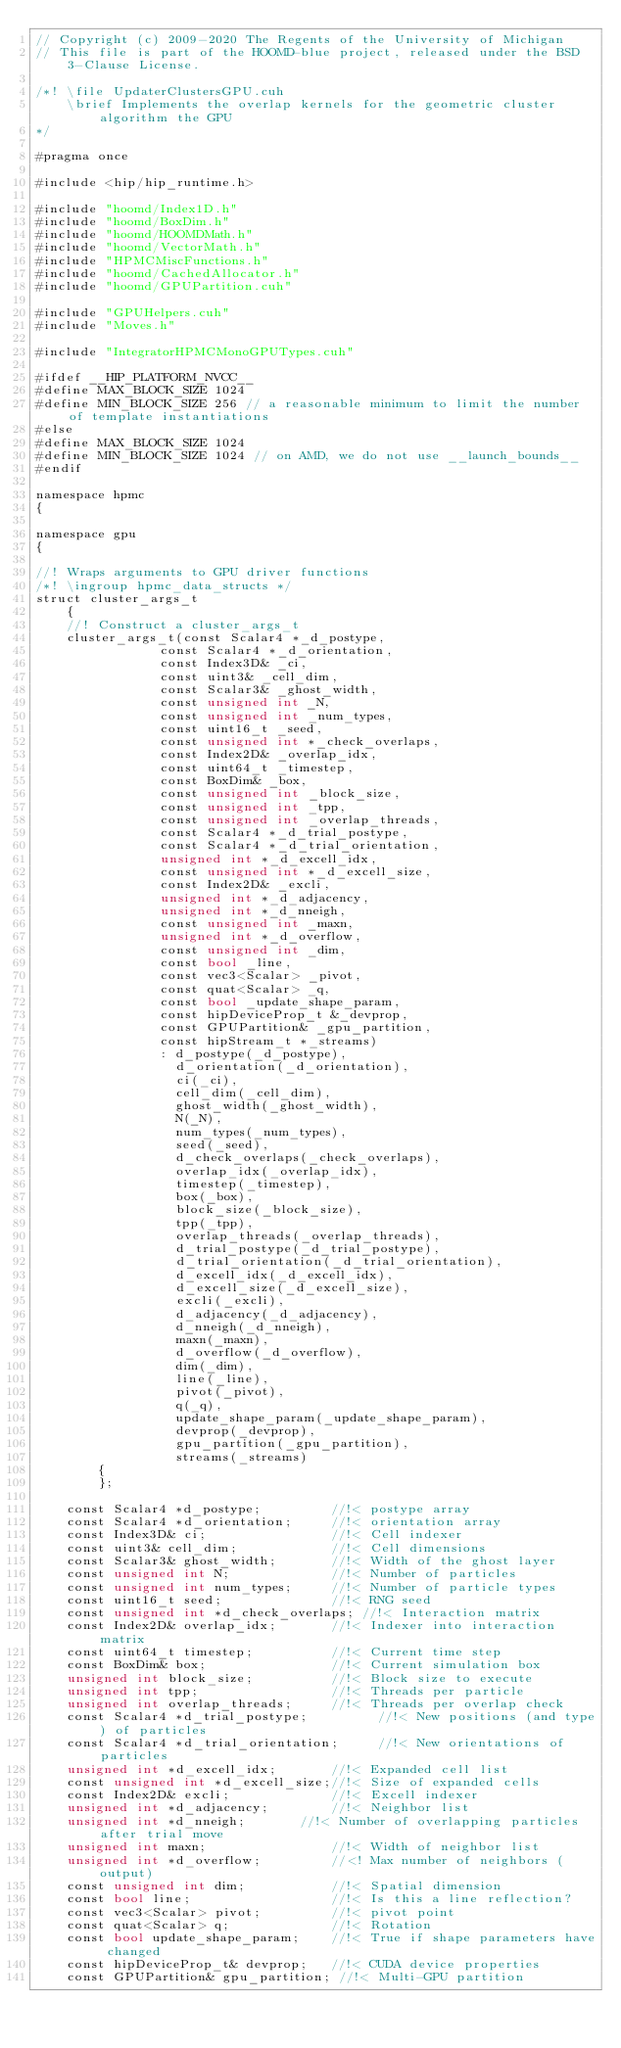<code> <loc_0><loc_0><loc_500><loc_500><_Cuda_>// Copyright (c) 2009-2020 The Regents of the University of Michigan
// This file is part of the HOOMD-blue project, released under the BSD 3-Clause License.

/*! \file UpdaterClustersGPU.cuh
    \brief Implements the overlap kernels for the geometric cluster algorithm the GPU
*/

#pragma once

#include <hip/hip_runtime.h>

#include "hoomd/Index1D.h"
#include "hoomd/BoxDim.h"
#include "hoomd/HOOMDMath.h"
#include "hoomd/VectorMath.h"
#include "HPMCMiscFunctions.h"
#include "hoomd/CachedAllocator.h"
#include "hoomd/GPUPartition.cuh"

#include "GPUHelpers.cuh"
#include "Moves.h"

#include "IntegratorHPMCMonoGPUTypes.cuh"

#ifdef __HIP_PLATFORM_NVCC__
#define MAX_BLOCK_SIZE 1024
#define MIN_BLOCK_SIZE 256 // a reasonable minimum to limit the number of template instantiations
#else
#define MAX_BLOCK_SIZE 1024
#define MIN_BLOCK_SIZE 1024 // on AMD, we do not use __launch_bounds__
#endif

namespace hpmc
{

namespace gpu
{

//! Wraps arguments to GPU driver functions
/*! \ingroup hpmc_data_structs */
struct cluster_args_t
    {
    //! Construct a cluster_args_t
    cluster_args_t(const Scalar4 *_d_postype,
                const Scalar4 *_d_orientation,
                const Index3D& _ci,
                const uint3& _cell_dim,
                const Scalar3& _ghost_width,
                const unsigned int _N,
                const unsigned int _num_types,
                const uint16_t _seed,
                const unsigned int *_check_overlaps,
                const Index2D& _overlap_idx,
                const uint64_t _timestep,
                const BoxDim& _box,
                const unsigned int _block_size,
                const unsigned int _tpp,
                const unsigned int _overlap_threads,
                const Scalar4 *_d_trial_postype,
                const Scalar4 *_d_trial_orientation,
                unsigned int *_d_excell_idx,
                const unsigned int *_d_excell_size,
                const Index2D& _excli,
                unsigned int *_d_adjacency,
                unsigned int *_d_nneigh,
                const unsigned int _maxn,
                unsigned int *_d_overflow,
                const unsigned int _dim,
                const bool _line,
                const vec3<Scalar> _pivot,
                const quat<Scalar> _q,
                const bool _update_shape_param,
                const hipDeviceProp_t &_devprop,
                const GPUPartition& _gpu_partition,
                const hipStream_t *_streams)
                : d_postype(_d_postype),
                  d_orientation(_d_orientation),
                  ci(_ci),
                  cell_dim(_cell_dim),
                  ghost_width(_ghost_width),
                  N(_N),
                  num_types(_num_types),
                  seed(_seed),
                  d_check_overlaps(_check_overlaps),
                  overlap_idx(_overlap_idx),
                  timestep(_timestep),
                  box(_box),
                  block_size(_block_size),
                  tpp(_tpp),
                  overlap_threads(_overlap_threads),
                  d_trial_postype(_d_trial_postype),
                  d_trial_orientation(_d_trial_orientation),
                  d_excell_idx(_d_excell_idx),
                  d_excell_size(_d_excell_size),
                  excli(_excli),
                  d_adjacency(_d_adjacency),
                  d_nneigh(_d_nneigh),
                  maxn(_maxn),
                  d_overflow(_d_overflow),
                  dim(_dim),
                  line(_line),
                  pivot(_pivot),
                  q(_q),
                  update_shape_param(_update_shape_param),
                  devprop(_devprop),
                  gpu_partition(_gpu_partition),
                  streams(_streams)
        {
        };

    const Scalar4 *d_postype;         //!< postype array
    const Scalar4 *d_orientation;     //!< orientation array
    const Index3D& ci;                //!< Cell indexer
    const uint3& cell_dim;            //!< Cell dimensions
    const Scalar3& ghost_width;       //!< Width of the ghost layer
    const unsigned int N;             //!< Number of particles
    const unsigned int num_types;     //!< Number of particle types
    const uint16_t seed;              //!< RNG seed
    const unsigned int *d_check_overlaps; //!< Interaction matrix
    const Index2D& overlap_idx;       //!< Indexer into interaction matrix
    const uint64_t timestep;          //!< Current time step
    const BoxDim& box;                //!< Current simulation box
    unsigned int block_size;          //!< Block size to execute
    unsigned int tpp;                 //!< Threads per particle
    unsigned int overlap_threads;     //!< Threads per overlap check
    const Scalar4 *d_trial_postype;         //!< New positions (and type) of particles
    const Scalar4 *d_trial_orientation;     //!< New orientations of particles
    unsigned int *d_excell_idx;       //!< Expanded cell list
    const unsigned int *d_excell_size;//!< Size of expanded cells
    const Index2D& excli;             //!< Excell indexer
    unsigned int *d_adjacency;        //!< Neighbor list
    unsigned int *d_nneigh;       //!< Number of overlapping particles after trial move
    unsigned int maxn;                //!< Width of neighbor list
    unsigned int *d_overflow;         //<! Max number of neighbors (output)
    const unsigned int dim;           //!< Spatial dimension
    const bool line;                  //!< Is this a line reflection?
    const vec3<Scalar> pivot;         //!< pivot point
    const quat<Scalar> q;             //!< Rotation
    const bool update_shape_param;    //!< True if shape parameters have changed
    const hipDeviceProp_t& devprop;   //!< CUDA device properties
    const GPUPartition& gpu_partition; //!< Multi-GPU partition</code> 